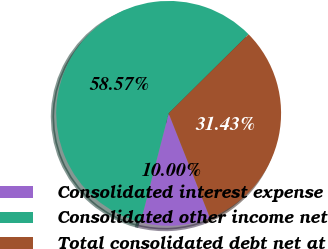<chart> <loc_0><loc_0><loc_500><loc_500><pie_chart><fcel>Consolidated interest expense<fcel>Consolidated other income net<fcel>Total consolidated debt net at<nl><fcel>10.0%<fcel>58.57%<fcel>31.43%<nl></chart> 